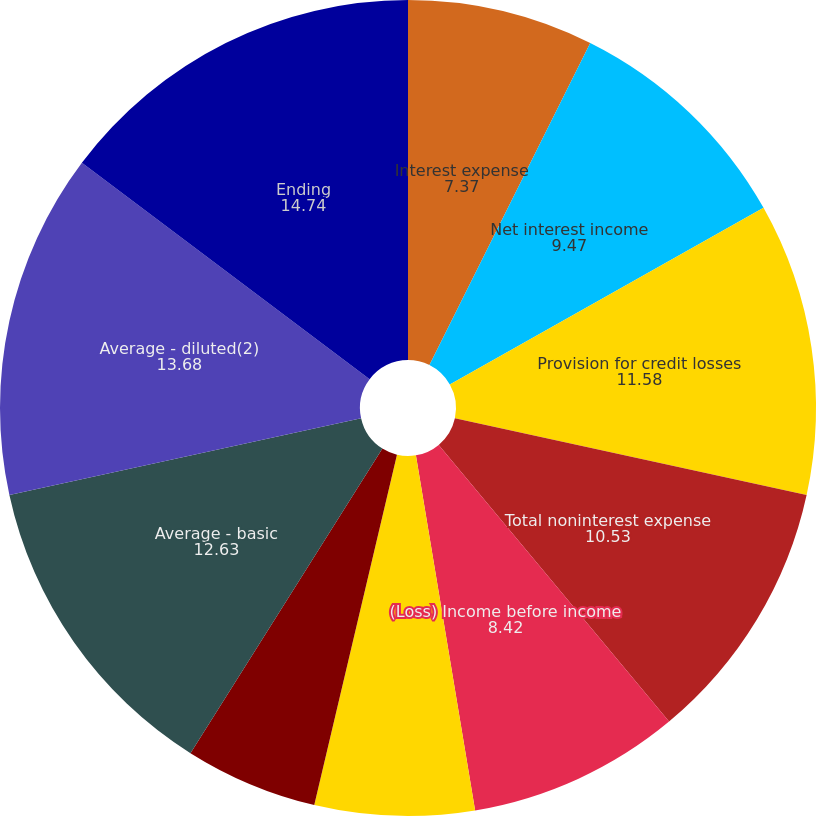<chart> <loc_0><loc_0><loc_500><loc_500><pie_chart><fcel>Interest expense<fcel>Net interest income<fcel>Provision for credit losses<fcel>Total noninterest expense<fcel>(Loss) Income before income<fcel>(Benefit) Provision for income<fcel>Dividendsonpreferred shares<fcel>Average - basic<fcel>Average - diluted(2)<fcel>Ending<nl><fcel>7.37%<fcel>9.47%<fcel>11.58%<fcel>10.53%<fcel>8.42%<fcel>6.32%<fcel>5.26%<fcel>12.63%<fcel>13.68%<fcel>14.74%<nl></chart> 